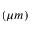Convert formula to latex. <formula><loc_0><loc_0><loc_500><loc_500>( \mu m )</formula> 